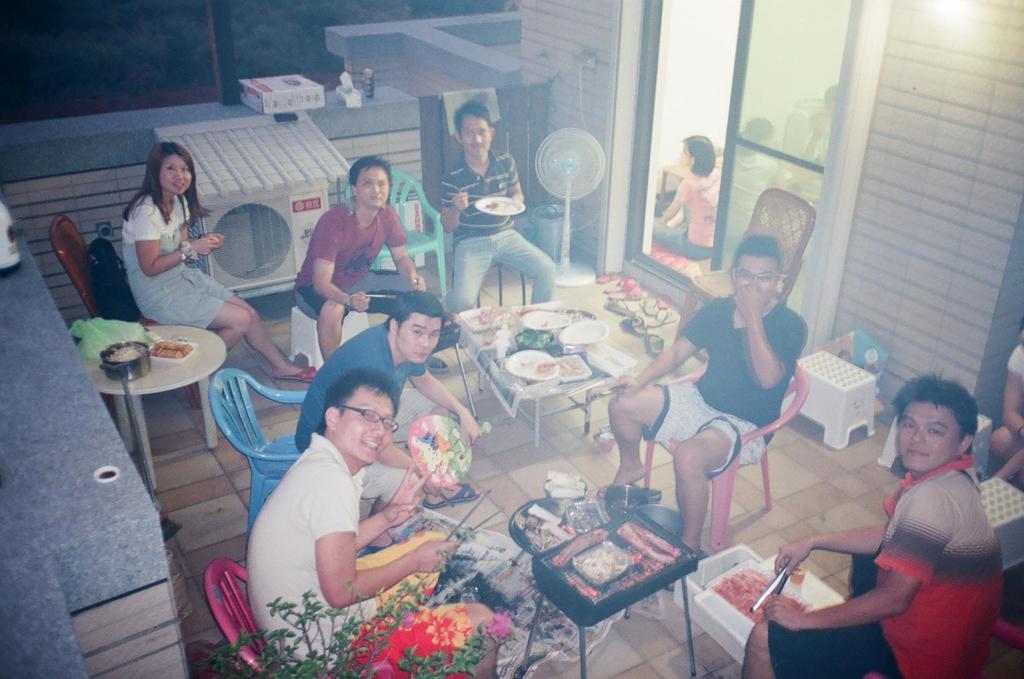Describe this image in one or two sentences. In this picture there are group of people who are sitting on the chair. There is a plate, bowl, cloth on the table. There is a white table. There is a box, food in the plate, green cloth on the other table. There is a device, fan and dust bin at the corner. There is a plant. 